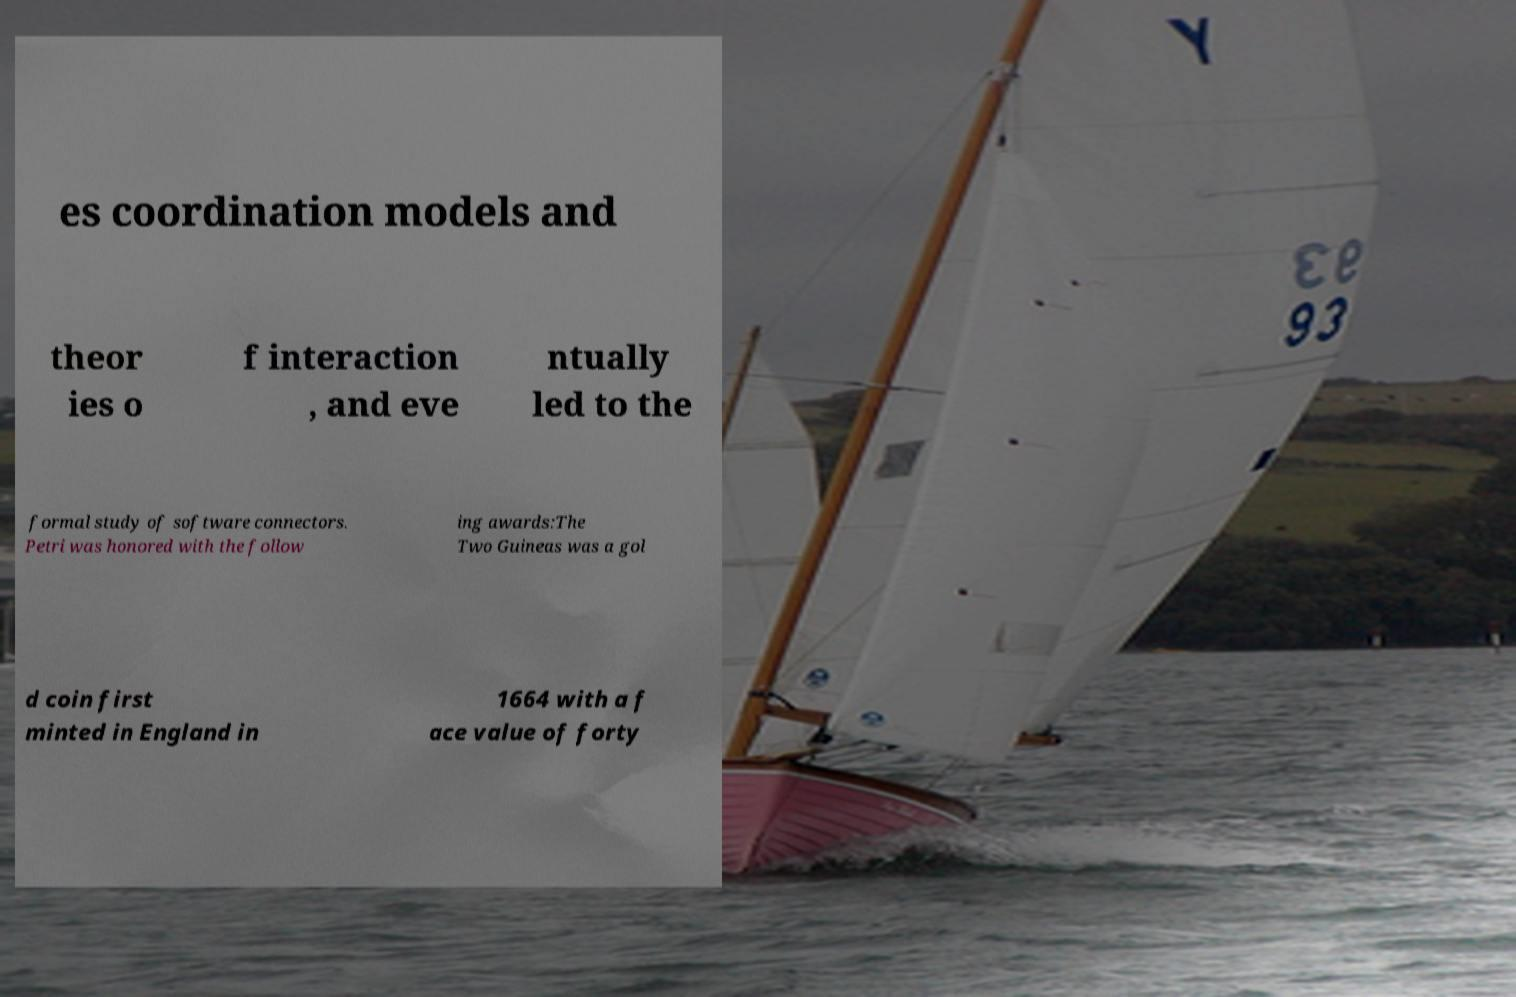What messages or text are displayed in this image? I need them in a readable, typed format. es coordination models and theor ies o f interaction , and eve ntually led to the formal study of software connectors. Petri was honored with the follow ing awards:The Two Guineas was a gol d coin first minted in England in 1664 with a f ace value of forty 